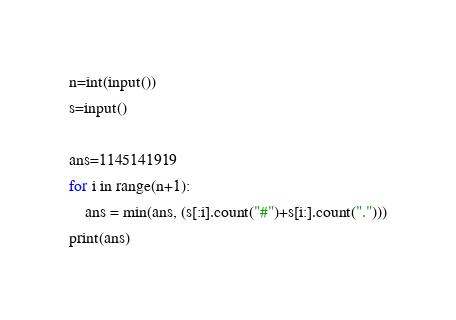<code> <loc_0><loc_0><loc_500><loc_500><_Python_>n=int(input())
s=input()

ans=1145141919
for i in range(n+1):
    ans = min(ans, (s[:i].count("#")+s[i:].count(".")))
print(ans)
</code> 